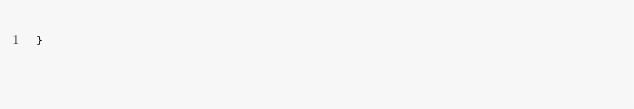Convert code to text. <code><loc_0><loc_0><loc_500><loc_500><_TypeScript_>}
</code> 